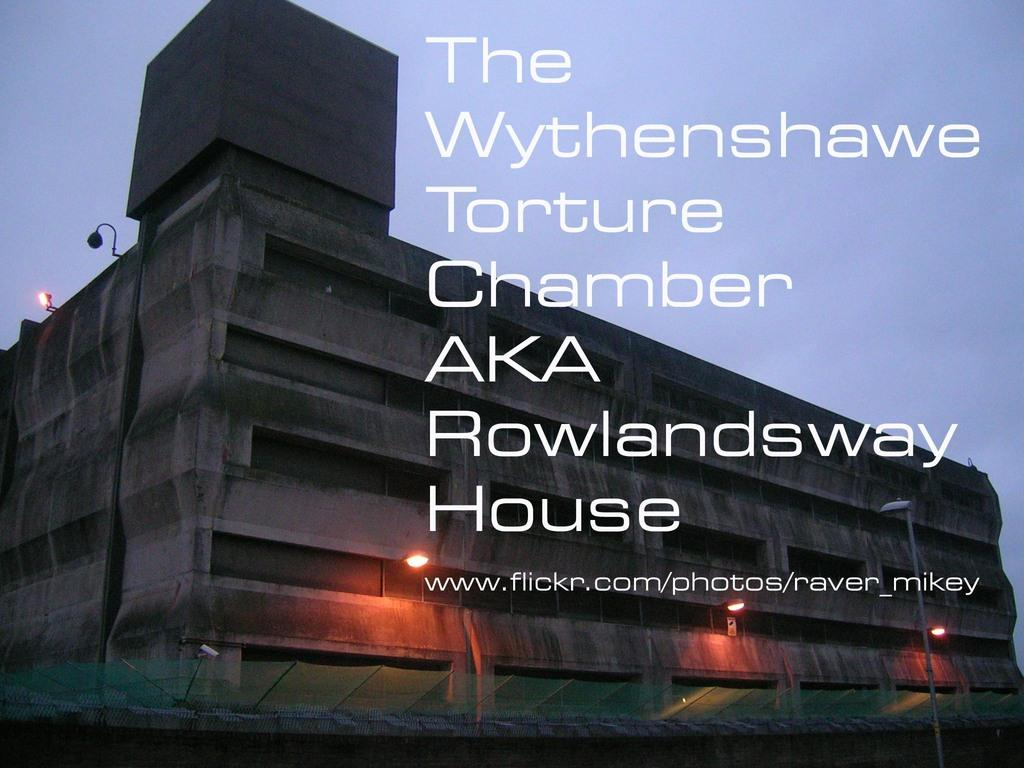What is featured on the poster in the image? The facts do not specify what is on the poster, so we cannot answer this question definitively. What type of structure is visible in the image? There is a concrete building in the image. What are the street light poles used for in the image? The street light poles on the ground in the image are used for supporting street lights. What is the condition of the sky in the image? The sky is clear in the image. What type of grass is growing on the honey-covered banana in the image? There is no grass, honey, or banana present in the image. 